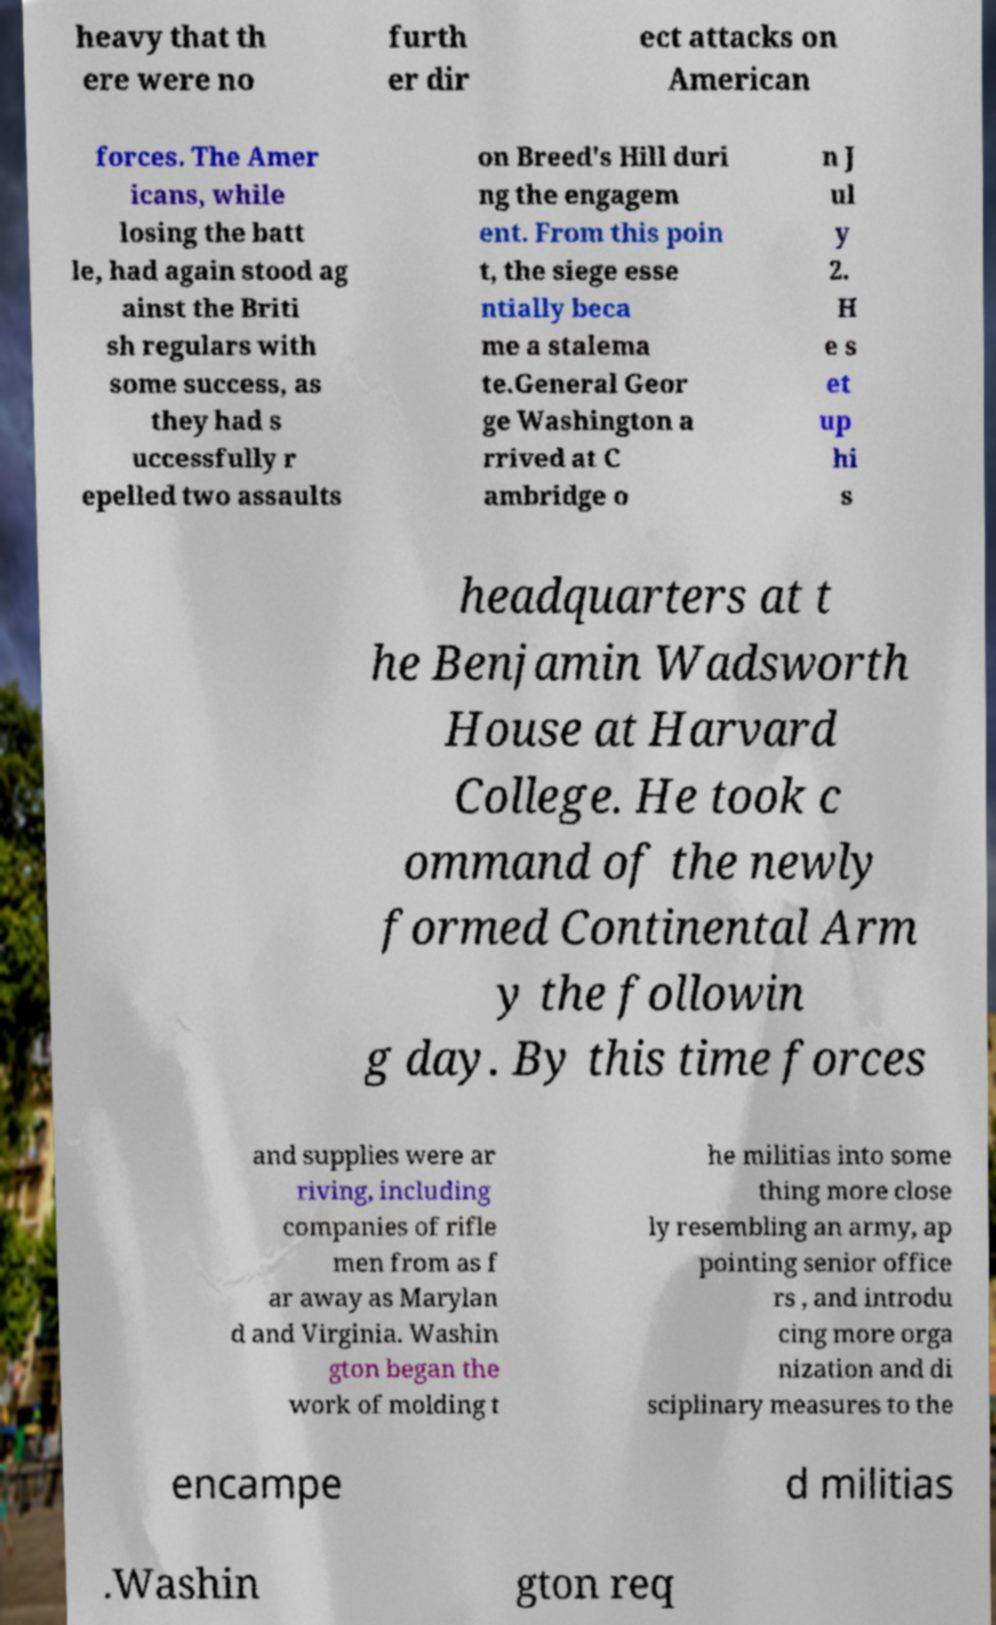There's text embedded in this image that I need extracted. Can you transcribe it verbatim? heavy that th ere were no furth er dir ect attacks on American forces. The Amer icans, while losing the batt le, had again stood ag ainst the Briti sh regulars with some success, as they had s uccessfully r epelled two assaults on Breed's Hill duri ng the engagem ent. From this poin t, the siege esse ntially beca me a stalema te.General Geor ge Washington a rrived at C ambridge o n J ul y 2. H e s et up hi s headquarters at t he Benjamin Wadsworth House at Harvard College. He took c ommand of the newly formed Continental Arm y the followin g day. By this time forces and supplies were ar riving, including companies of rifle men from as f ar away as Marylan d and Virginia. Washin gton began the work of molding t he militias into some thing more close ly resembling an army, ap pointing senior office rs , and introdu cing more orga nization and di sciplinary measures to the encampe d militias .Washin gton req 